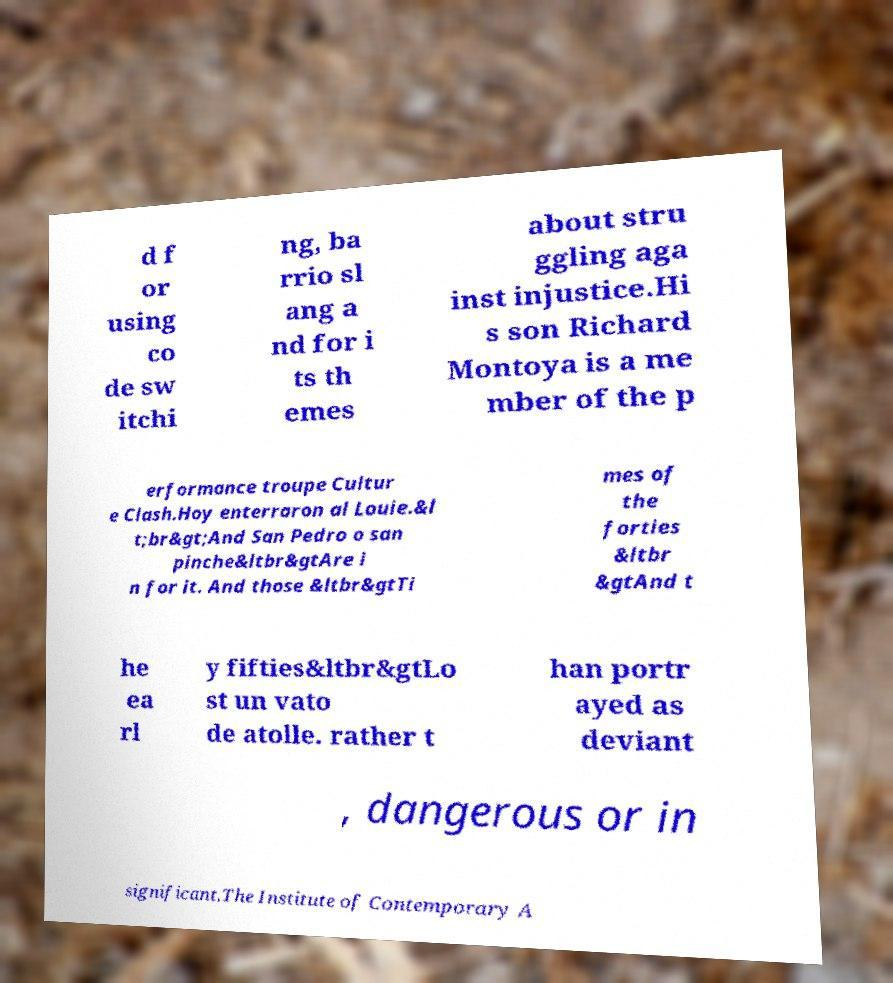Please identify and transcribe the text found in this image. d f or using co de sw itchi ng, ba rrio sl ang a nd for i ts th emes about stru ggling aga inst injustice.Hi s son Richard Montoya is a me mber of the p erformance troupe Cultur e Clash.Hoy enterraron al Louie.&l t;br&gt;And San Pedro o san pinche&ltbr&gtAre i n for it. And those &ltbr&gtTi mes of the forties &ltbr &gtAnd t he ea rl y fifties&ltbr&gtLo st un vato de atolle. rather t han portr ayed as deviant , dangerous or in significant.The Institute of Contemporary A 